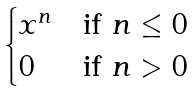<formula> <loc_0><loc_0><loc_500><loc_500>\begin{cases} x ^ { n } & \text {if } n \leq 0 \\ 0 & \text {if } n > 0 \end{cases}</formula> 